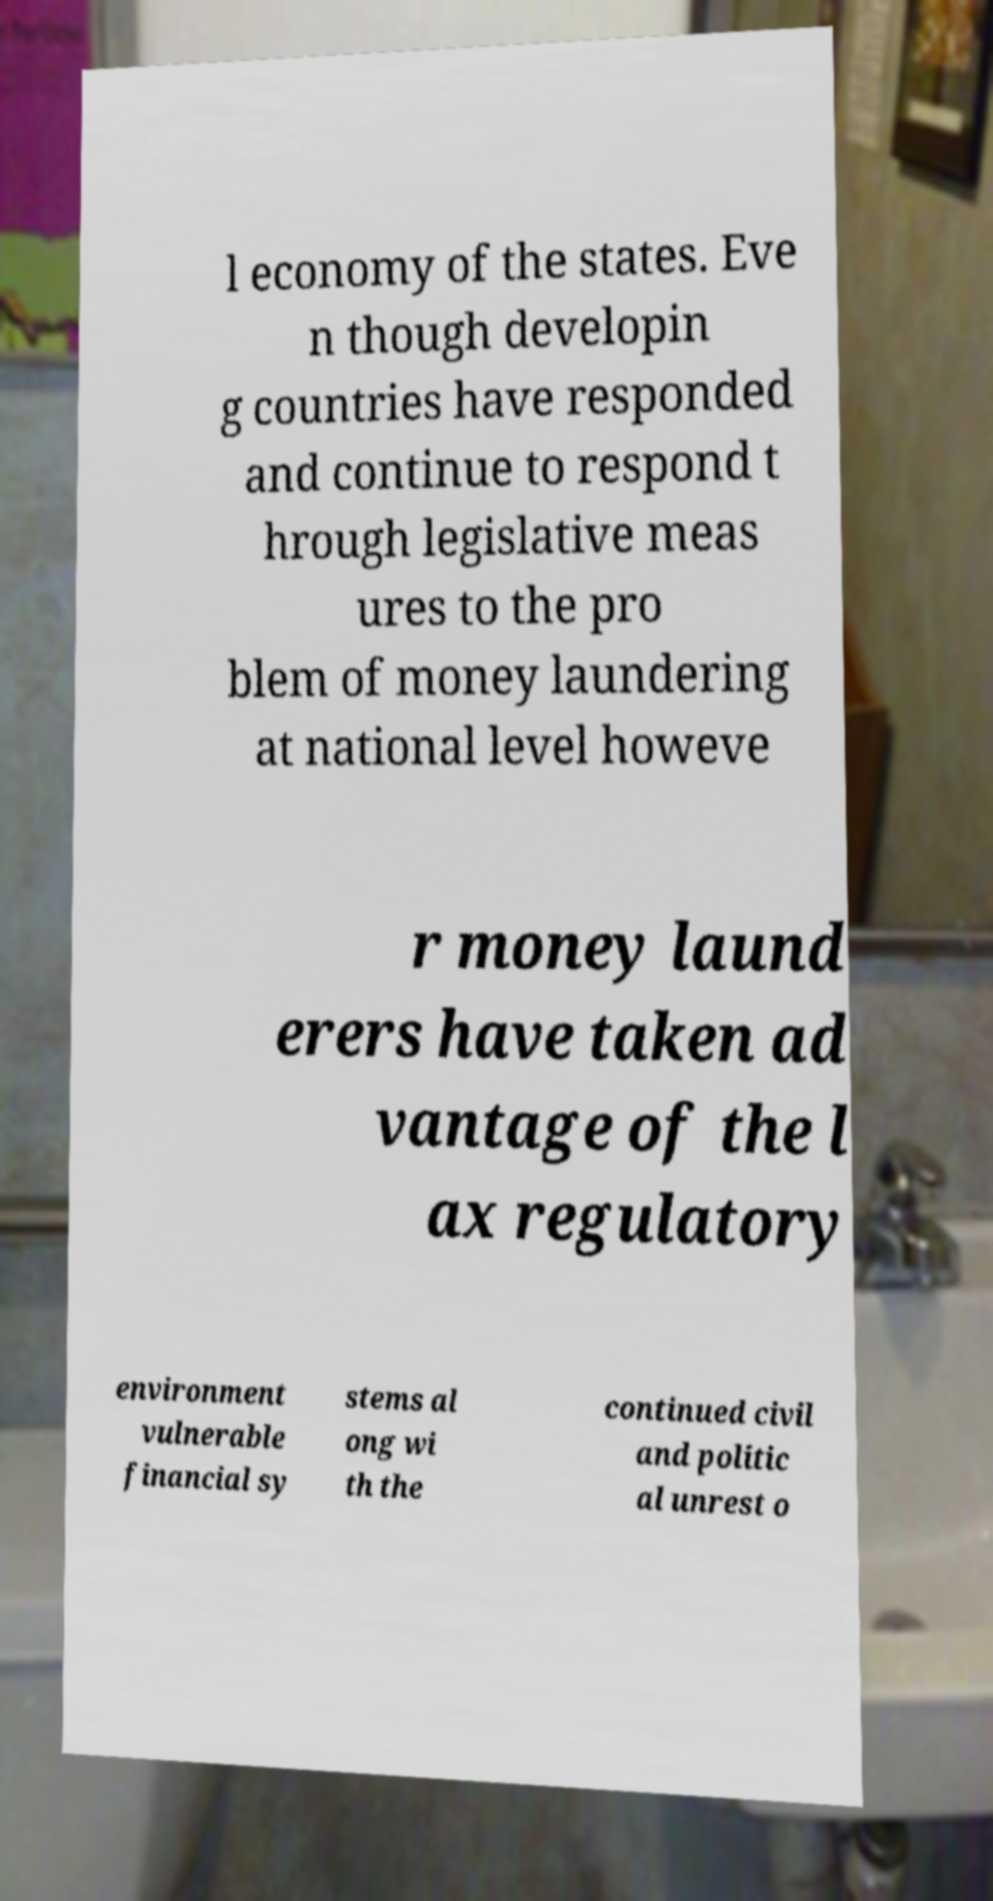Can you accurately transcribe the text from the provided image for me? l economy of the states. Eve n though developin g countries have responded and continue to respond t hrough legislative meas ures to the pro blem of money laundering at national level howeve r money laund erers have taken ad vantage of the l ax regulatory environment vulnerable financial sy stems al ong wi th the continued civil and politic al unrest o 